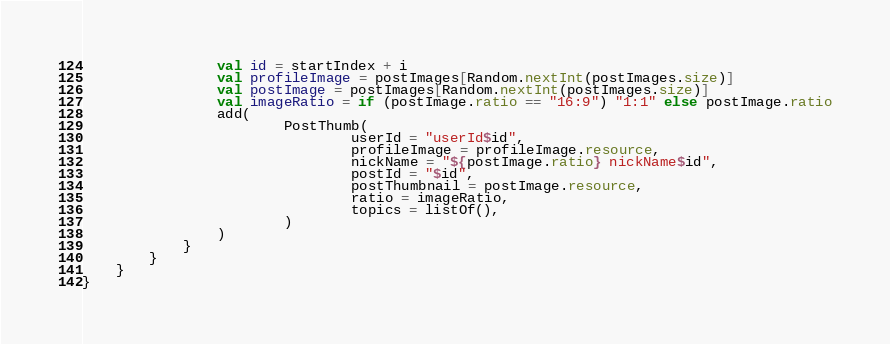<code> <loc_0><loc_0><loc_500><loc_500><_Kotlin_>                val id = startIndex + i
                val profileImage = postImages[Random.nextInt(postImages.size)]
                val postImage = postImages[Random.nextInt(postImages.size)]
                val imageRatio = if (postImage.ratio == "16:9") "1:1" else postImage.ratio
                add(
                        PostThumb(
                                userId = "userId$id",
                                profileImage = profileImage.resource,
                                nickName = "${postImage.ratio} nickName$id",
                                postId = "$id",
                                postThumbnail = postImage.resource,
                                ratio = imageRatio,
                                topics = listOf(),
                        )
                )
            }
        }
    }
}</code> 